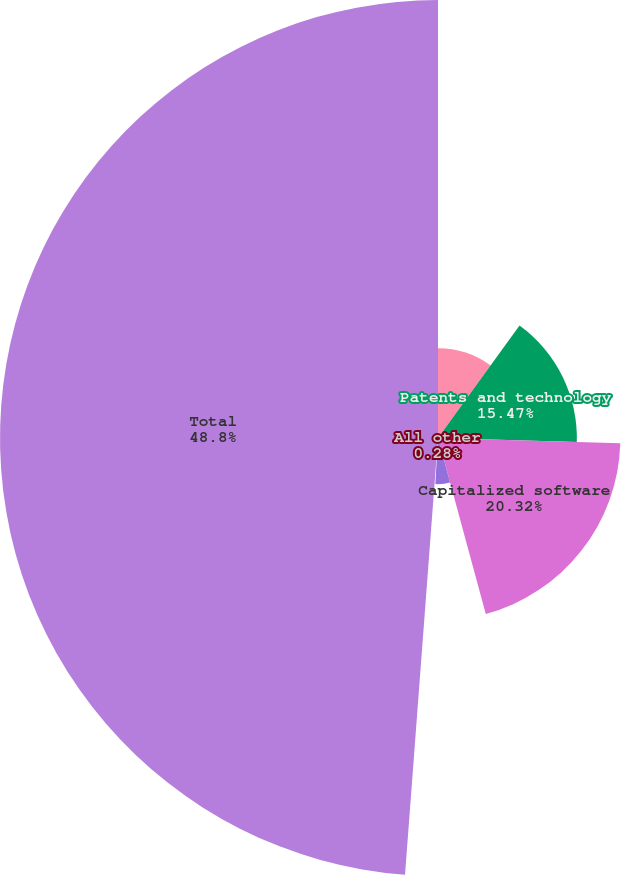Convert chart. <chart><loc_0><loc_0><loc_500><loc_500><pie_chart><fcel>Customer-related<fcel>Patents and technology<fcel>Capitalized software<fcel>Trademarks<fcel>All other<fcel>Total<nl><fcel>9.99%<fcel>15.47%<fcel>20.32%<fcel>5.14%<fcel>0.28%<fcel>48.8%<nl></chart> 